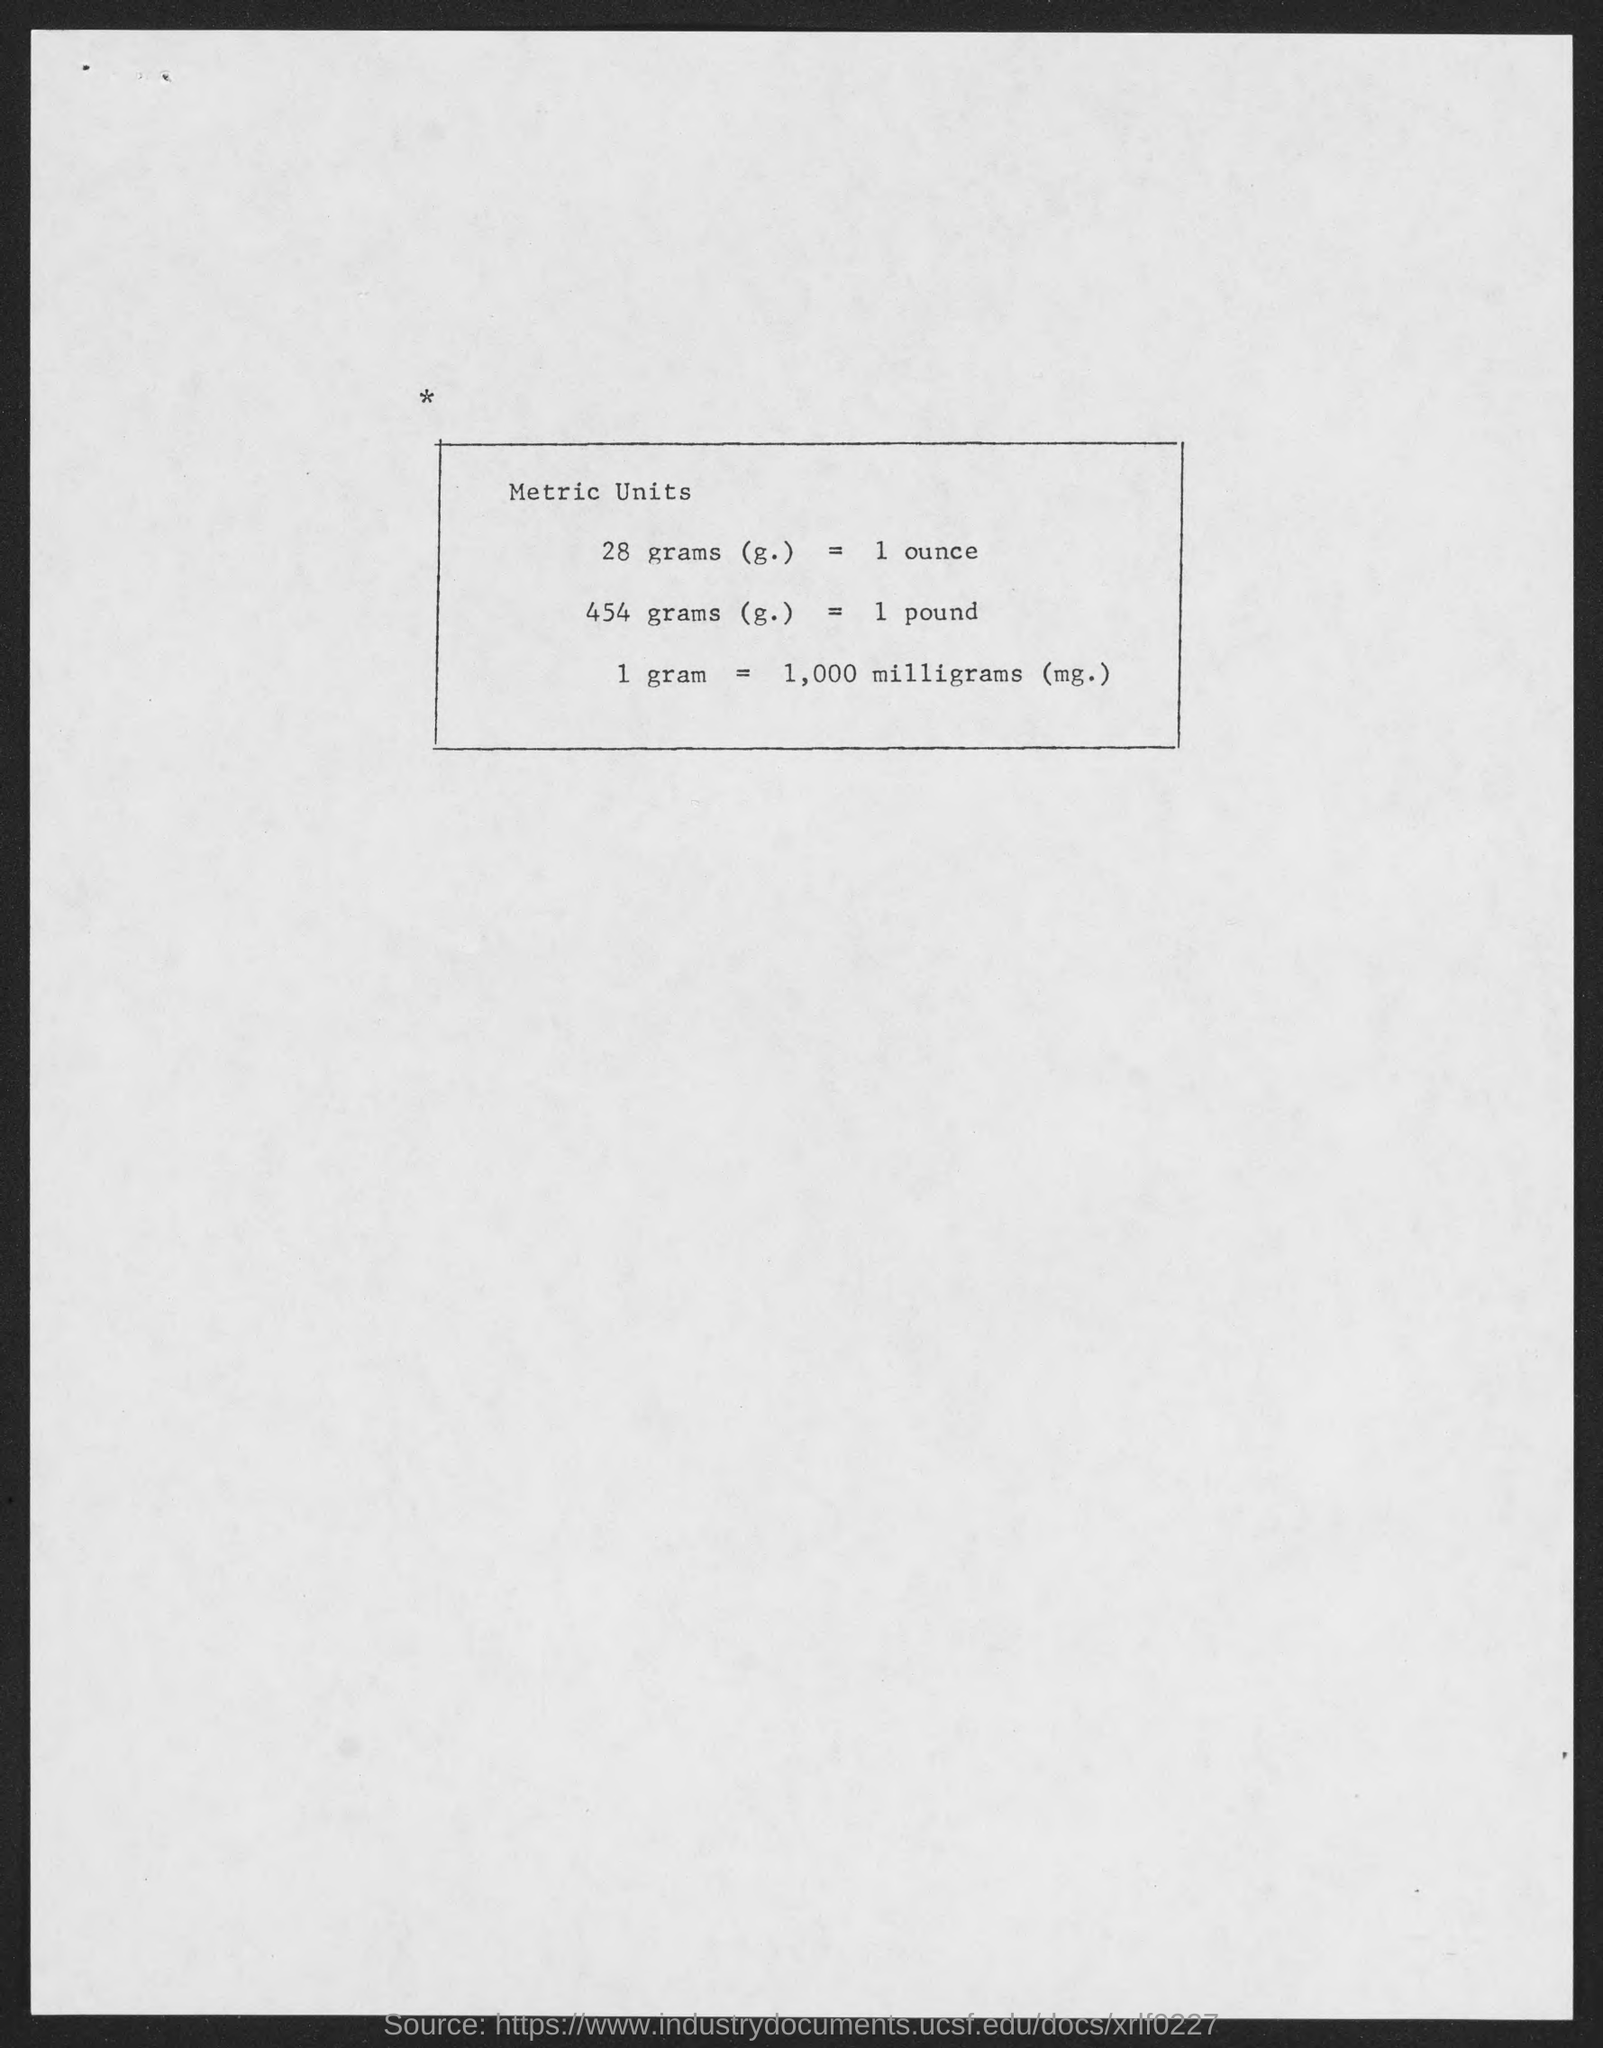What is 28 grams (g.) equals to?
Give a very brief answer. 1 ounce. What is 454 grams (g.) equals to ?
Provide a succinct answer. 1 pound. 